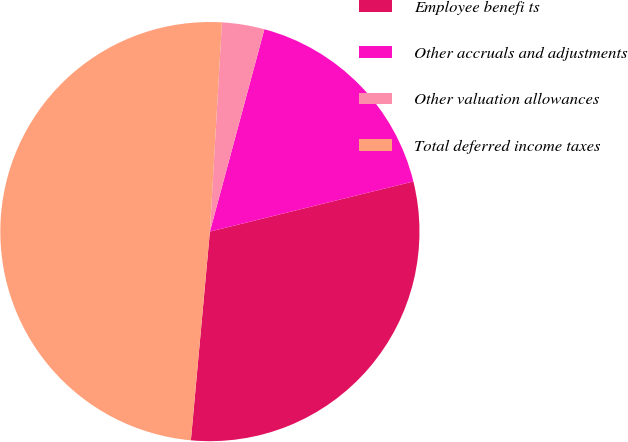Convert chart. <chart><loc_0><loc_0><loc_500><loc_500><pie_chart><fcel>Employee benefi ts<fcel>Other accruals and adjustments<fcel>Other valuation allowances<fcel>Total deferred income taxes<nl><fcel>30.29%<fcel>16.97%<fcel>3.27%<fcel>49.47%<nl></chart> 